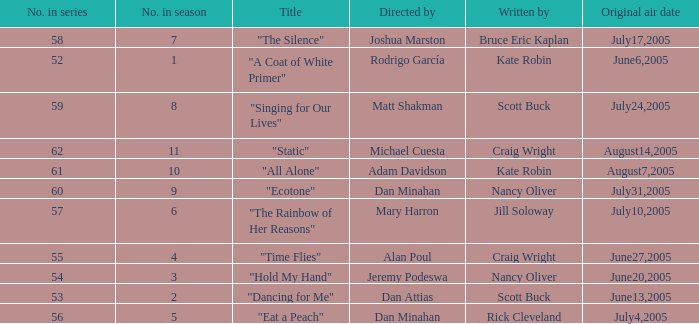Help me parse the entirety of this table. {'header': ['No. in series', 'No. in season', 'Title', 'Directed by', 'Written by', 'Original air date'], 'rows': [['58', '7', '"The Silence"', 'Joshua Marston', 'Bruce Eric Kaplan', 'July17,2005'], ['52', '1', '"A Coat of White Primer"', 'Rodrigo García', 'Kate Robin', 'June6,2005'], ['59', '8', '"Singing for Our Lives"', 'Matt Shakman', 'Scott Buck', 'July24,2005'], ['62', '11', '"Static"', 'Michael Cuesta', 'Craig Wright', 'August14,2005'], ['61', '10', '"All Alone"', 'Adam Davidson', 'Kate Robin', 'August7,2005'], ['60', '9', '"Ecotone"', 'Dan Minahan', 'Nancy Oliver', 'July31,2005'], ['57', '6', '"The Rainbow of Her Reasons"', 'Mary Harron', 'Jill Soloway', 'July10,2005'], ['55', '4', '"Time Flies"', 'Alan Poul', 'Craig Wright', 'June27,2005'], ['54', '3', '"Hold My Hand"', 'Jeremy Podeswa', 'Nancy Oliver', 'June20,2005'], ['53', '2', '"Dancing for Me"', 'Dan Attias', 'Scott Buck', 'June13,2005'], ['56', '5', '"Eat a Peach"', 'Dan Minahan', 'Rick Cleveland', 'July4,2005']]} What was the name of the episode that was directed by Mary Harron? "The Rainbow of Her Reasons". 